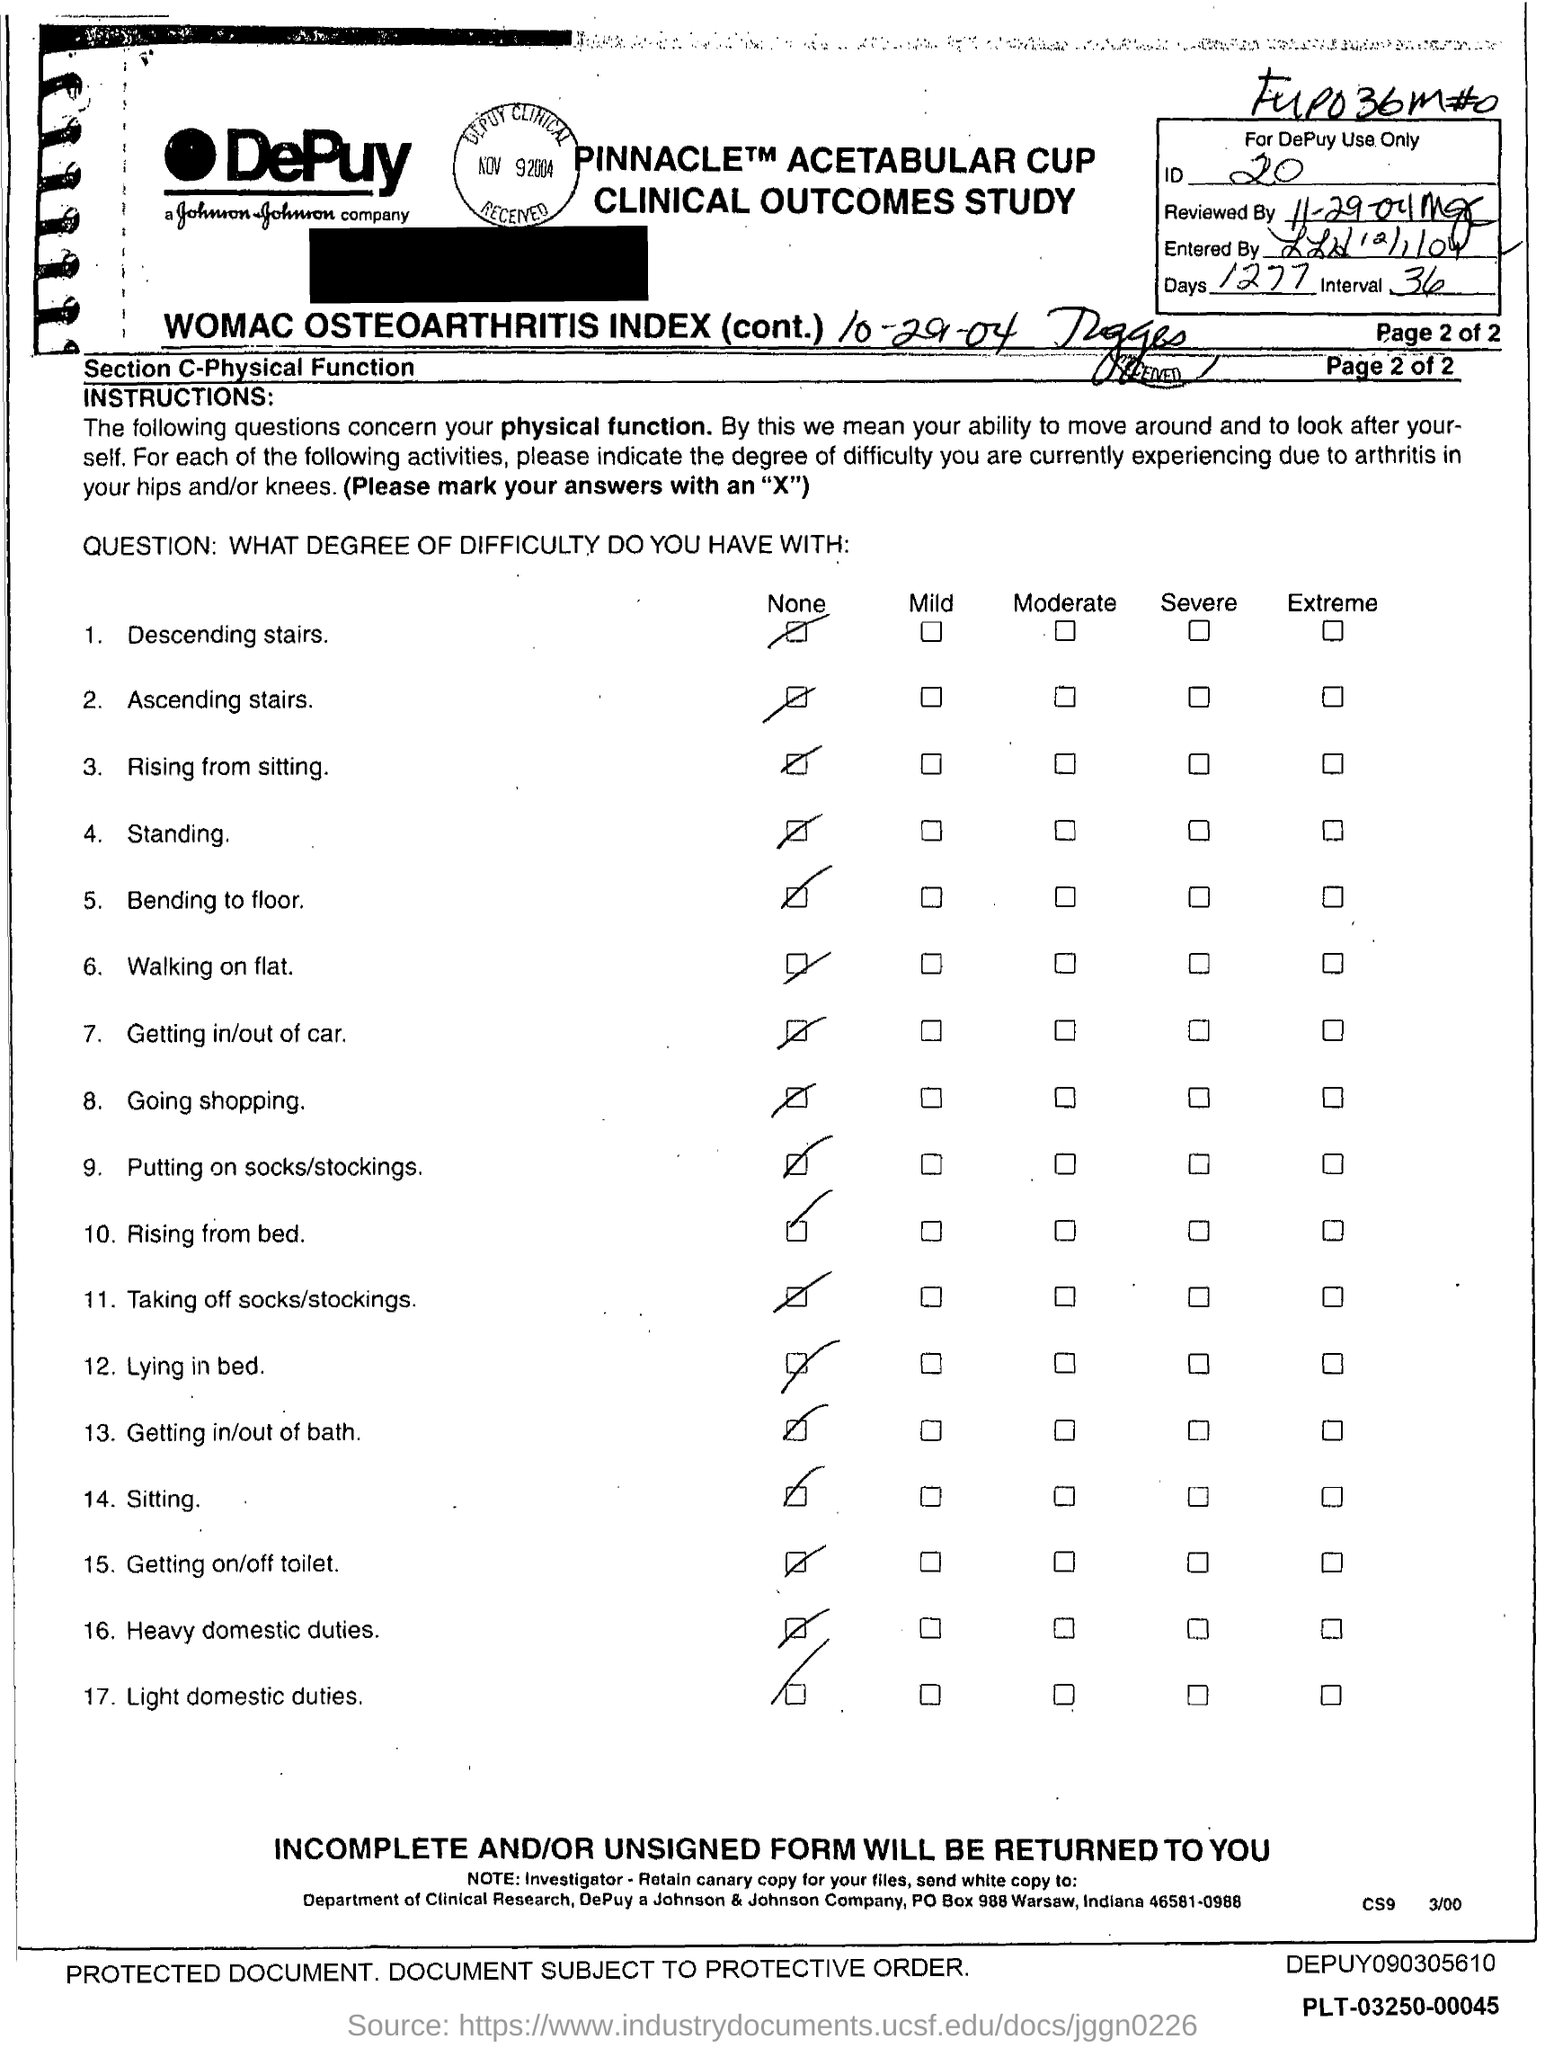What is the ID Number?
Your response must be concise. 20. What is the number of days?
Your response must be concise. 1277. 